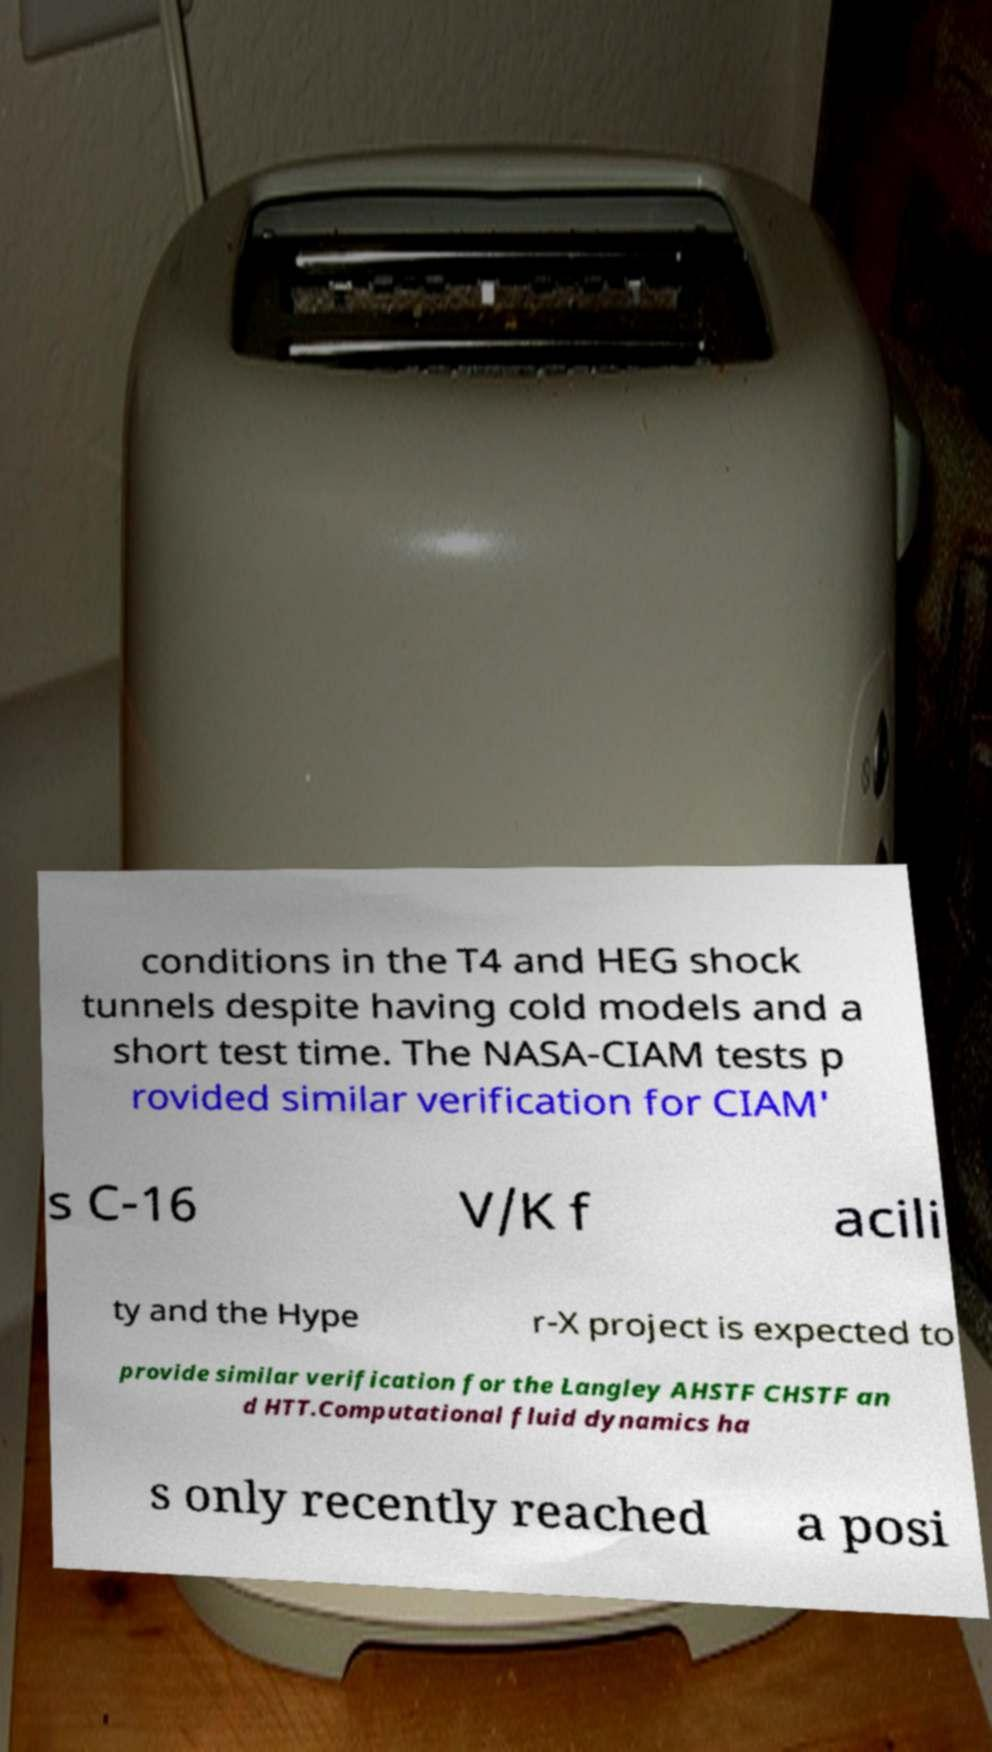There's text embedded in this image that I need extracted. Can you transcribe it verbatim? conditions in the T4 and HEG shock tunnels despite having cold models and a short test time. The NASA-CIAM tests p rovided similar verification for CIAM' s C-16 V/K f acili ty and the Hype r-X project is expected to provide similar verification for the Langley AHSTF CHSTF an d HTT.Computational fluid dynamics ha s only recently reached a posi 